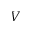<formula> <loc_0><loc_0><loc_500><loc_500>V</formula> 